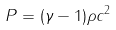<formula> <loc_0><loc_0><loc_500><loc_500>P = ( \gamma - 1 ) \rho c ^ { 2 }</formula> 